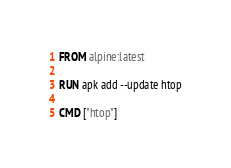<code> <loc_0><loc_0><loc_500><loc_500><_Dockerfile_>FROM alpine:latest

RUN apk add --update htop

CMD ["htop"]
</code> 